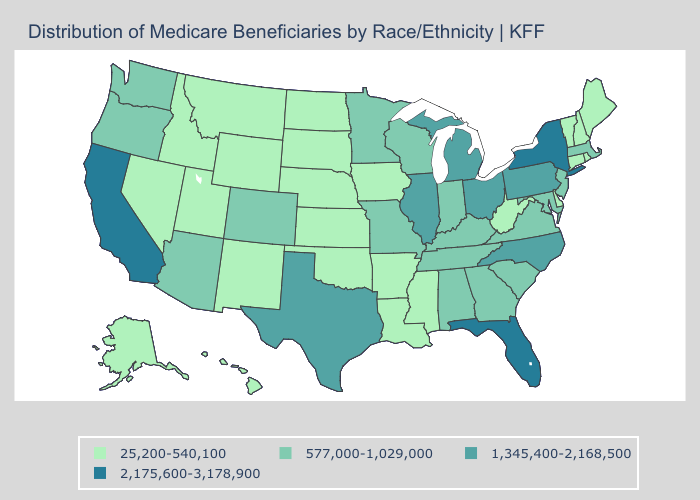Is the legend a continuous bar?
Quick response, please. No. Does Indiana have the same value as Arkansas?
Short answer required. No. Among the states that border Minnesota , which have the highest value?
Write a very short answer. Wisconsin. Name the states that have a value in the range 25,200-540,100?
Write a very short answer. Alaska, Arkansas, Connecticut, Delaware, Hawaii, Idaho, Iowa, Kansas, Louisiana, Maine, Mississippi, Montana, Nebraska, Nevada, New Hampshire, New Mexico, North Dakota, Oklahoma, Rhode Island, South Dakota, Utah, Vermont, West Virginia, Wyoming. Which states have the highest value in the USA?
Concise answer only. California, Florida, New York. Does Florida have the lowest value in the USA?
Quick response, please. No. What is the lowest value in the South?
Write a very short answer. 25,200-540,100. What is the value of Georgia?
Keep it brief. 577,000-1,029,000. Among the states that border Pennsylvania , which have the lowest value?
Concise answer only. Delaware, West Virginia. What is the lowest value in the USA?
Be succinct. 25,200-540,100. Which states hav the highest value in the South?
Keep it brief. Florida. Name the states that have a value in the range 2,175,600-3,178,900?
Be succinct. California, Florida, New York. What is the highest value in the Northeast ?
Short answer required. 2,175,600-3,178,900. What is the value of Kentucky?
Be succinct. 577,000-1,029,000. Among the states that border Illinois , does Kentucky have the highest value?
Short answer required. Yes. 